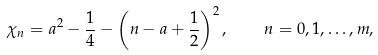<formula> <loc_0><loc_0><loc_500><loc_500>\chi _ { n } = a ^ { 2 } - \frac { 1 } { 4 } - \left ( n - a + \frac { 1 } { 2 } \right ) ^ { 2 } , \quad n = 0 , 1 , \dots , m ,</formula> 